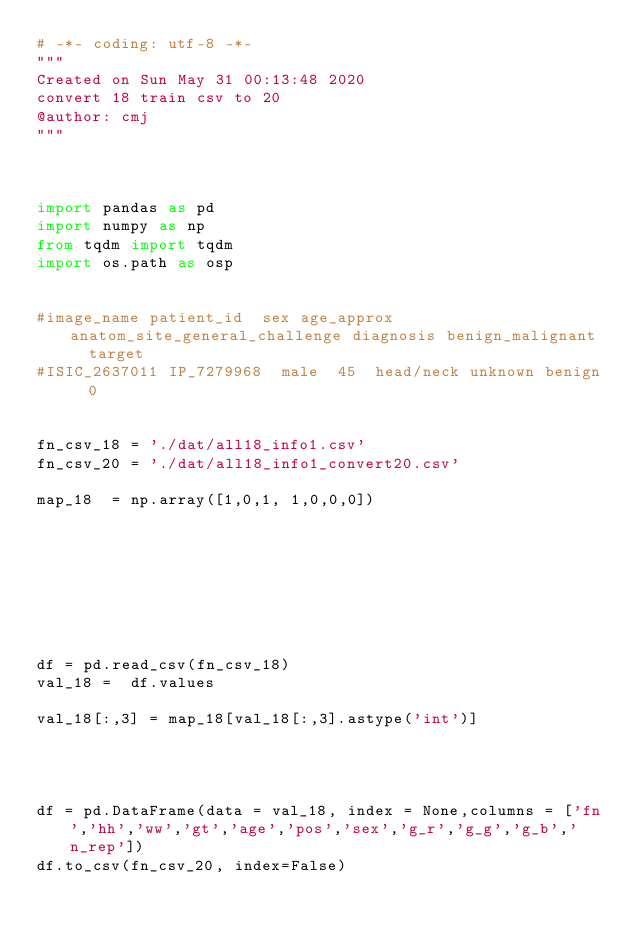Convert code to text. <code><loc_0><loc_0><loc_500><loc_500><_Python_># -*- coding: utf-8 -*-
"""
Created on Sun May 31 00:13:48 2020
convert 18 train csv to 20
@author: cmj
"""



import pandas as pd
import numpy as np
from tqdm import tqdm
import os.path as osp


#image_name	patient_id	sex	age_approx	anatom_site_general_challenge	diagnosis	benign_malignant	target
#ISIC_2637011	IP_7279968	male	45	head/neck	unknown	benign	0


fn_csv_18 = './dat/all18_info1.csv'
fn_csv_20 = './dat/all18_info1_convert20.csv'

map_18  = np.array([1,0,1, 1,0,0,0])








df = pd.read_csv(fn_csv_18)
val_18 =  df.values

val_18[:,3] = map_18[val_18[:,3].astype('int')]




df = pd.DataFrame(data = val_18, index = None,columns = ['fn','hh','ww','gt','age','pos','sex','g_r','g_g','g_b','n_rep'])
df.to_csv(fn_csv_20, index=False)</code> 